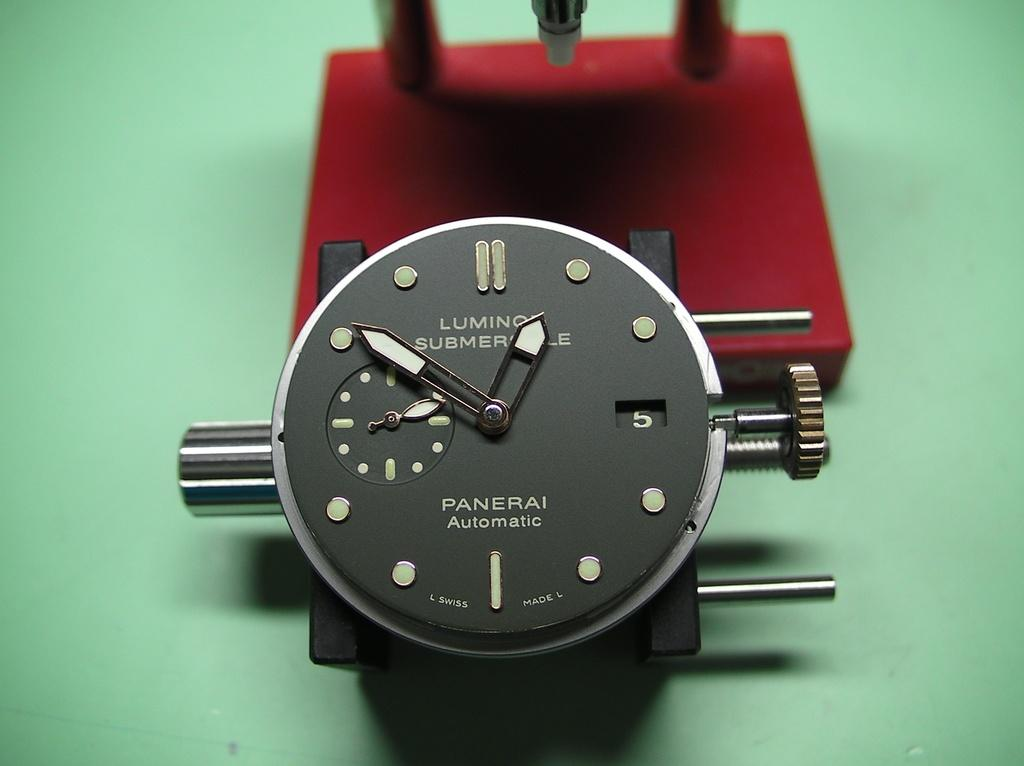Provide a one-sentence caption for the provided image. A black Panerai watches displays the time of 12:51. 